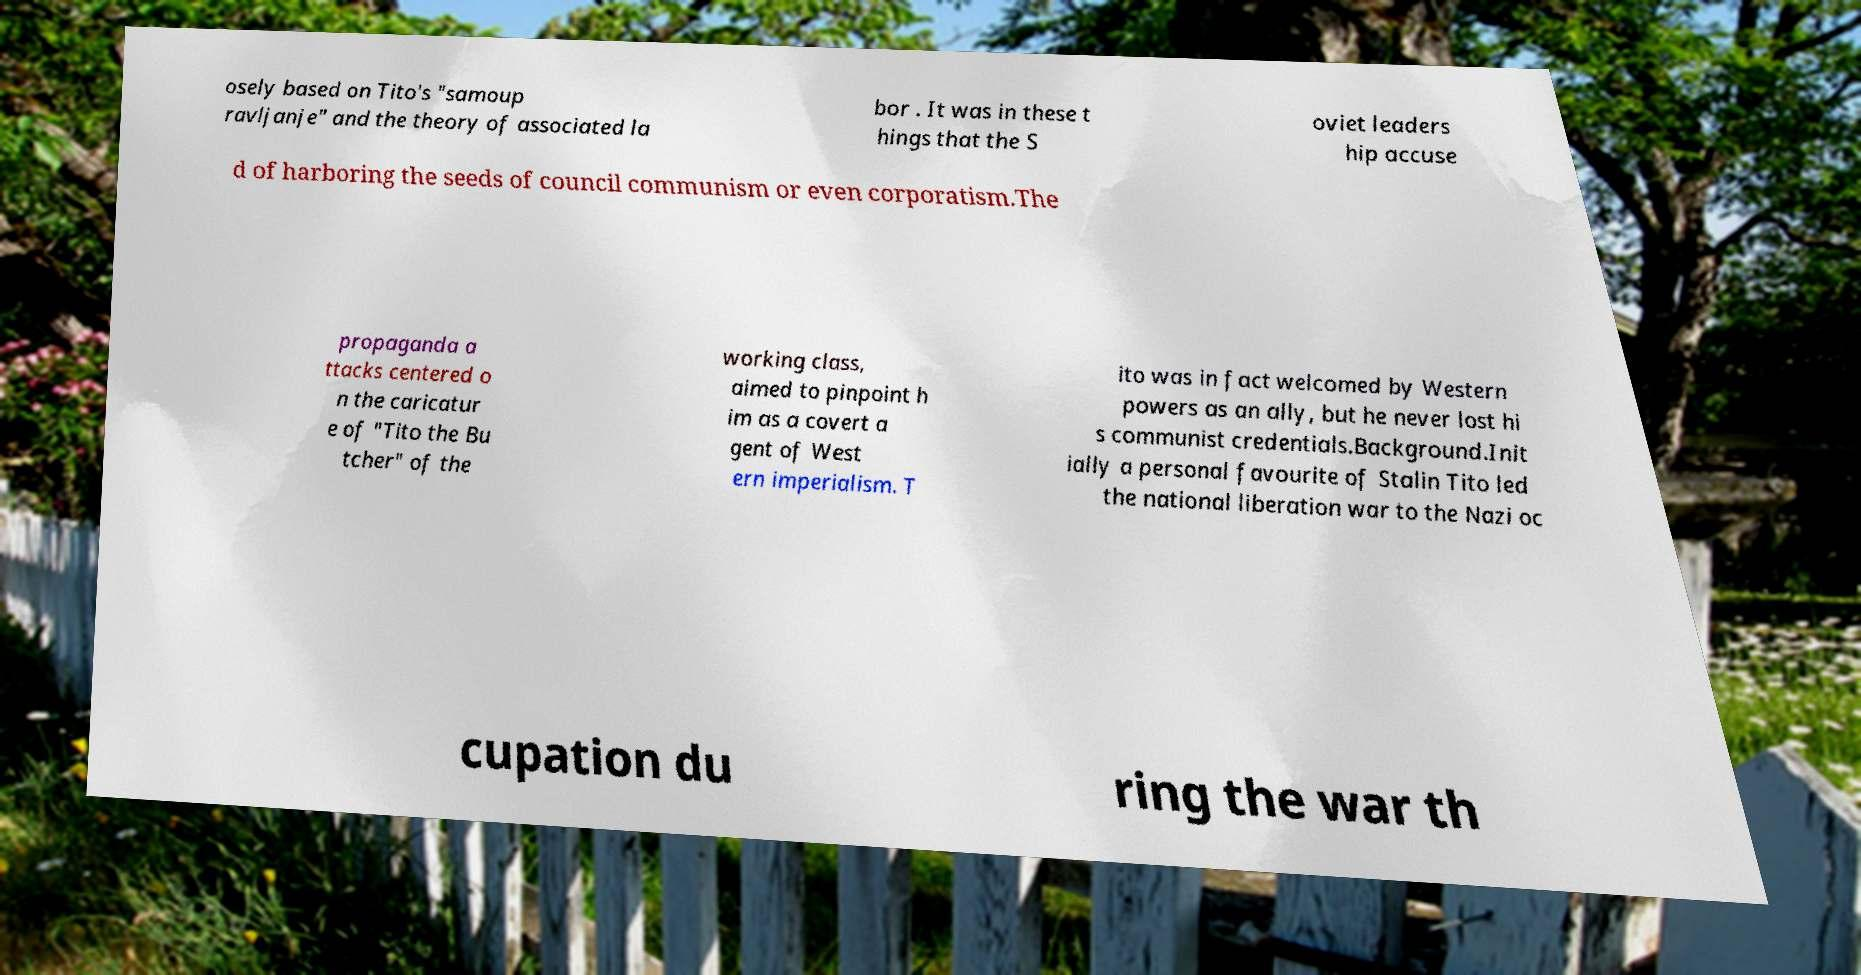Could you extract and type out the text from this image? osely based on Tito's "samoup ravljanje" and the theory of associated la bor . It was in these t hings that the S oviet leaders hip accuse d of harboring the seeds of council communism or even corporatism.The propaganda a ttacks centered o n the caricatur e of "Tito the Bu tcher" of the working class, aimed to pinpoint h im as a covert a gent of West ern imperialism. T ito was in fact welcomed by Western powers as an ally, but he never lost hi s communist credentials.Background.Init ially a personal favourite of Stalin Tito led the national liberation war to the Nazi oc cupation du ring the war th 